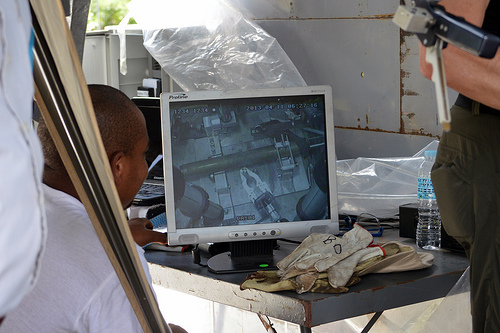<image>
Is there a computer in front of the glove? No. The computer is not in front of the glove. The spatial positioning shows a different relationship between these objects. 